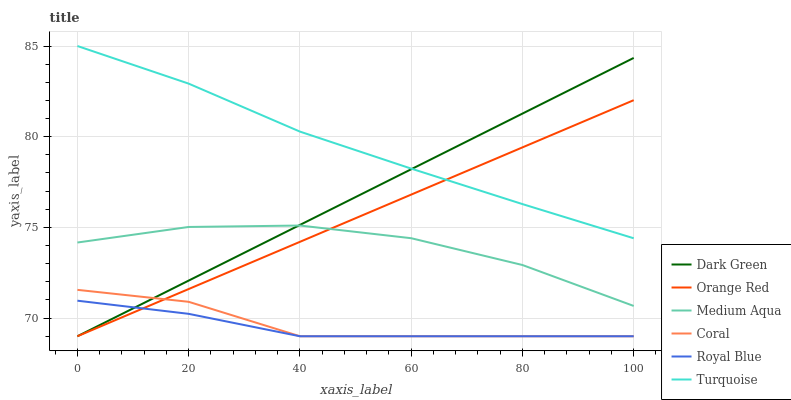Does Royal Blue have the minimum area under the curve?
Answer yes or no. Yes. Does Turquoise have the maximum area under the curve?
Answer yes or no. Yes. Does Coral have the minimum area under the curve?
Answer yes or no. No. Does Coral have the maximum area under the curve?
Answer yes or no. No. Is Dark Green the smoothest?
Answer yes or no. Yes. Is Coral the roughest?
Answer yes or no. Yes. Is Royal Blue the smoothest?
Answer yes or no. No. Is Royal Blue the roughest?
Answer yes or no. No. Does Coral have the lowest value?
Answer yes or no. Yes. Does Medium Aqua have the lowest value?
Answer yes or no. No. Does Turquoise have the highest value?
Answer yes or no. Yes. Does Coral have the highest value?
Answer yes or no. No. Is Coral less than Medium Aqua?
Answer yes or no. Yes. Is Turquoise greater than Coral?
Answer yes or no. Yes. Does Coral intersect Dark Green?
Answer yes or no. Yes. Is Coral less than Dark Green?
Answer yes or no. No. Is Coral greater than Dark Green?
Answer yes or no. No. Does Coral intersect Medium Aqua?
Answer yes or no. No. 